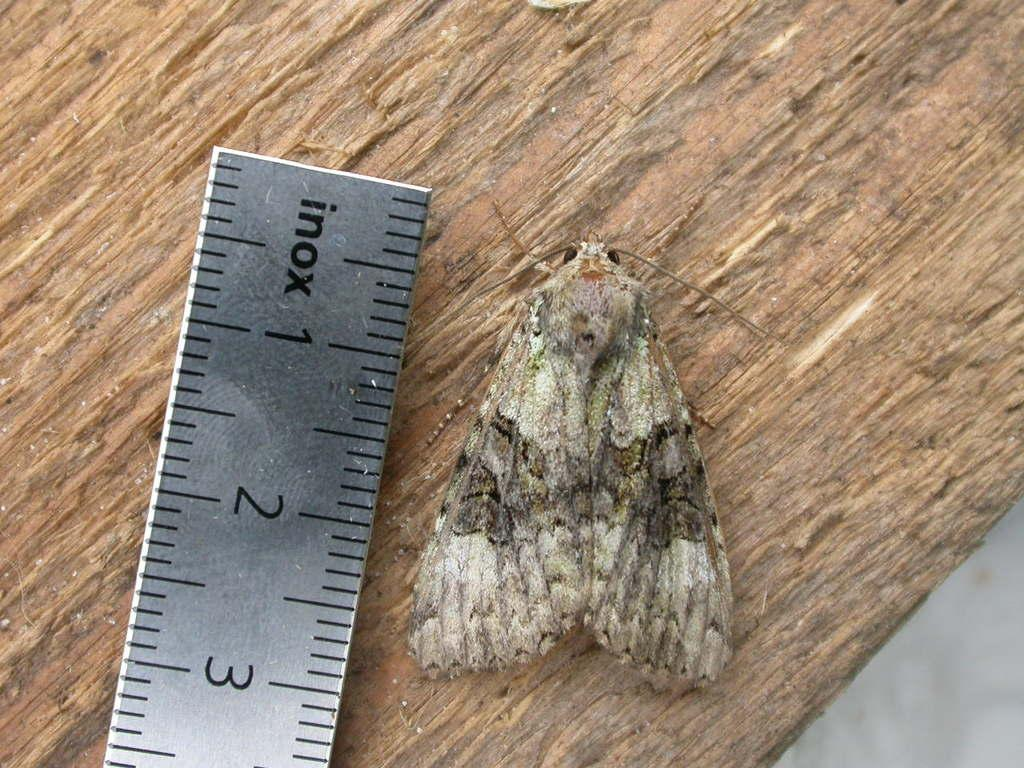<image>
Write a terse but informative summary of the picture. A moth is being measured by an inox metal ruler. 